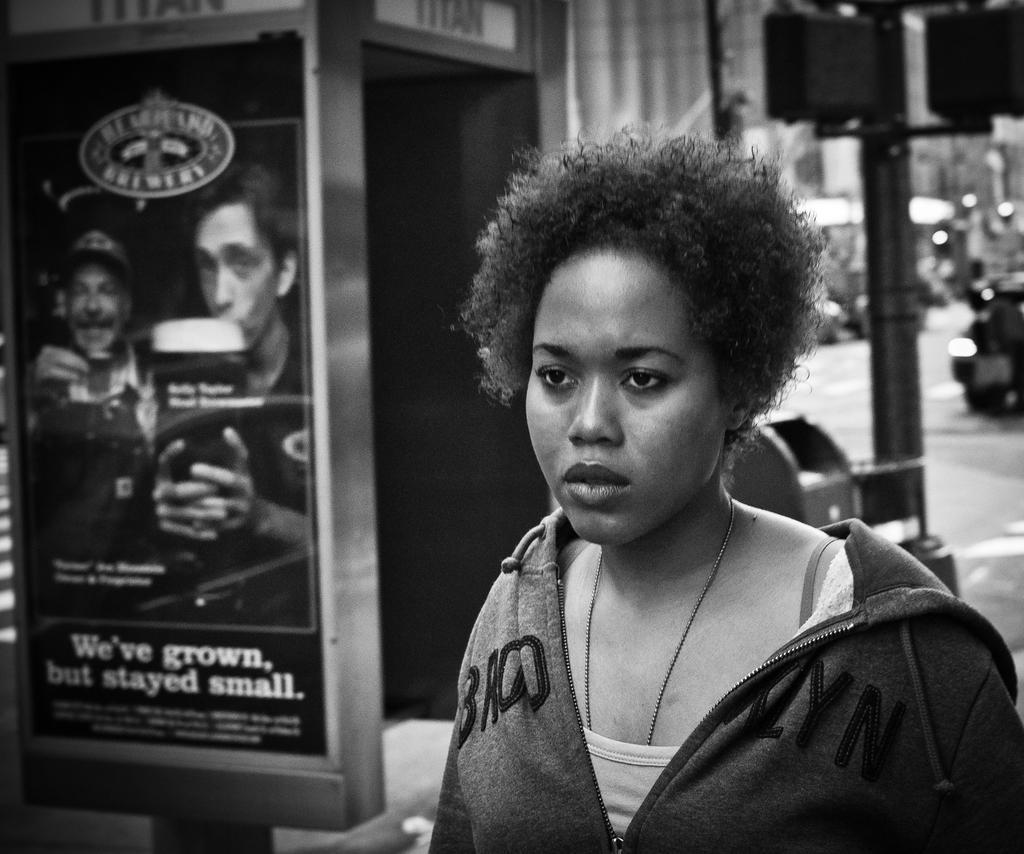Can you describe this image briefly? This is a black and white picture. The woman at the bottom of the picture wearing jacket is standing. Beside her, we see the poster of the man pasted on the board and behind her, we see traffic signal and vehicles moving on the road. There is a building in the background. 